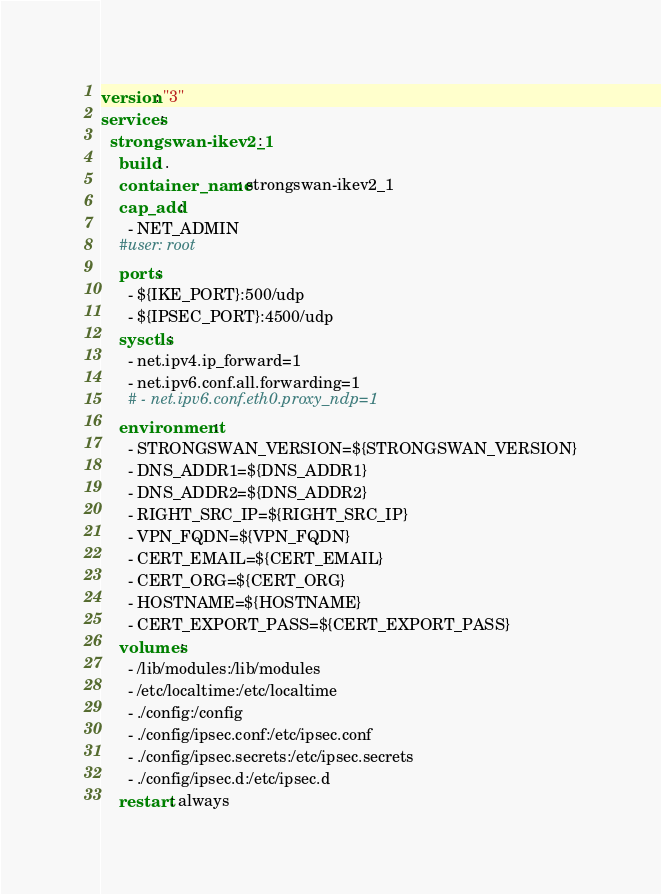<code> <loc_0><loc_0><loc_500><loc_500><_YAML_>version: "3"
services:
  strongswan-ikev2_1:
    build: .
    container_name: strongswan-ikev2_1
    cap_add:
      - NET_ADMIN
    #user: root
    ports:
      - ${IKE_PORT}:500/udp
      - ${IPSEC_PORT}:4500/udp
    sysctls:
      - net.ipv4.ip_forward=1
      - net.ipv6.conf.all.forwarding=1
      # - net.ipv6.conf.eth0.proxy_ndp=1
    environment:
      - STRONGSWAN_VERSION=${STRONGSWAN_VERSION}
      - DNS_ADDR1=${DNS_ADDR1}
      - DNS_ADDR2=${DNS_ADDR2}
      - RIGHT_SRC_IP=${RIGHT_SRC_IP}
      - VPN_FQDN=${VPN_FQDN}
      - CERT_EMAIL=${CERT_EMAIL}
      - CERT_ORG=${CERT_ORG}
      - HOSTNAME=${HOSTNAME}
      - CERT_EXPORT_PASS=${CERT_EXPORT_PASS}
    volumes:
      - /lib/modules:/lib/modules
      - /etc/localtime:/etc/localtime
      - ./config:/config
      - ./config/ipsec.conf:/etc/ipsec.conf
      - ./config/ipsec.secrets:/etc/ipsec.secrets
      - ./config/ipsec.d:/etc/ipsec.d
    restart: always
</code> 